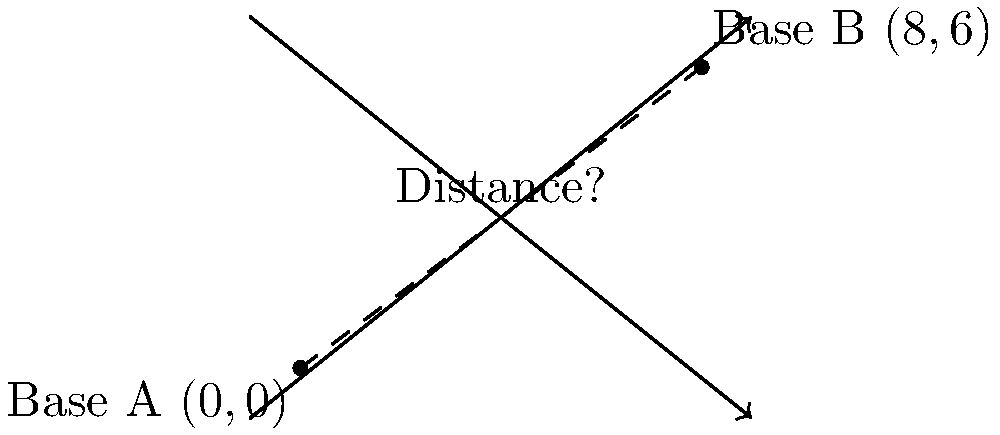As a retired military officer, you are tasked with calculating the distance between two strategic bases for a training exercise. Base A is located at coordinates (0,0), and Base B is at coordinates (8,6) on a tactical grid where each unit represents 10 kilometers. Using the distance formula, determine the straight-line distance between these two bases in kilometers. To solve this problem, we'll use the distance formula derived from the Pythagorean theorem:

$d = \sqrt{(x_2-x_1)^2 + (y_2-y_1)^2}$

Where $(x_1,y_1)$ are the coordinates of Base A, and $(x_2,y_2)$ are the coordinates of Base B.

Step 1: Identify the coordinates
Base A: $(x_1,y_1) = (0,0)$
Base B: $(x_2,y_2) = (8,6)$

Step 2: Plug the coordinates into the distance formula
$d = \sqrt{(8-0)^2 + (6-0)^2}$

Step 3: Simplify the expression inside the parentheses
$d = \sqrt{8^2 + 6^2}$

Step 4: Calculate the squares
$d = \sqrt{64 + 36}$

Step 5: Add the values under the square root
$d = \sqrt{100}$

Step 6: Simplify the square root
$d = 10$

Step 7: Convert the result to kilometers
Since each unit represents 10 km, we multiply our result by 10:
$10 \times 10 = 100$ km

Therefore, the straight-line distance between Base A and Base B is 100 kilometers.
Answer: 100 km 